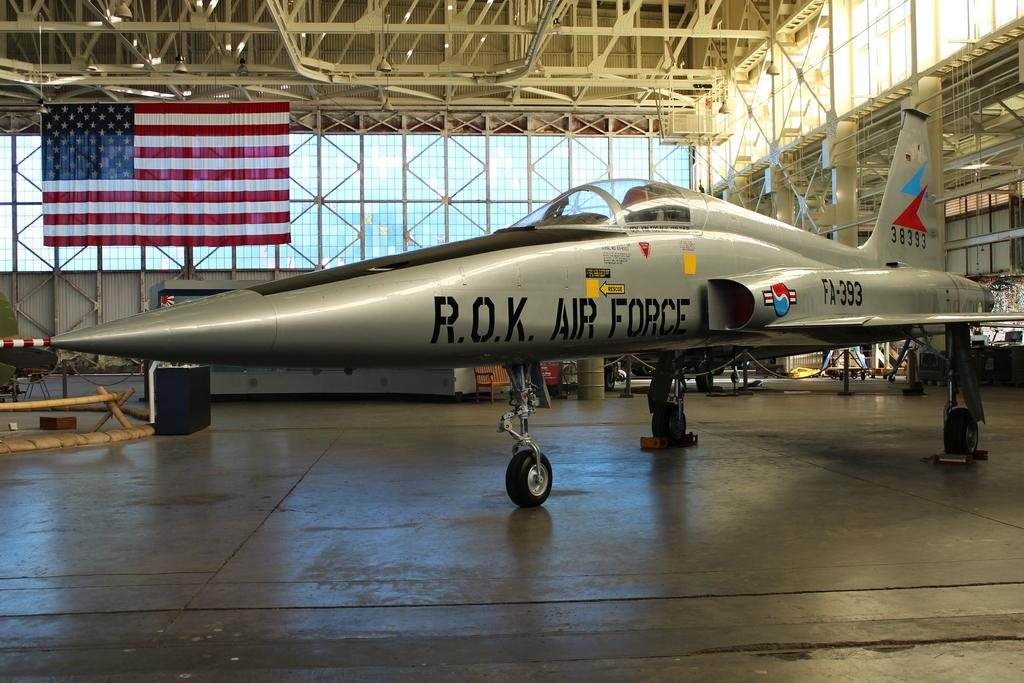Provide a one-sentence caption for the provided image. A R.O.K. Air Force aircraft sitting in a hangar. 